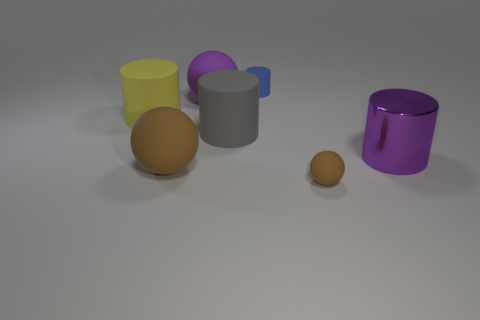Subtract all big gray cylinders. How many cylinders are left? 3 Subtract all yellow cylinders. How many brown balls are left? 2 Subtract 2 cylinders. How many cylinders are left? 2 Subtract all purple spheres. How many spheres are left? 2 Add 3 big shiny objects. How many objects exist? 10 Subtract all cylinders. How many objects are left? 3 Subtract all gray cylinders. Subtract all yellow cubes. How many cylinders are left? 3 Subtract 0 cyan blocks. How many objects are left? 7 Subtract all blue rubber things. Subtract all purple cylinders. How many objects are left? 5 Add 1 rubber objects. How many rubber objects are left? 7 